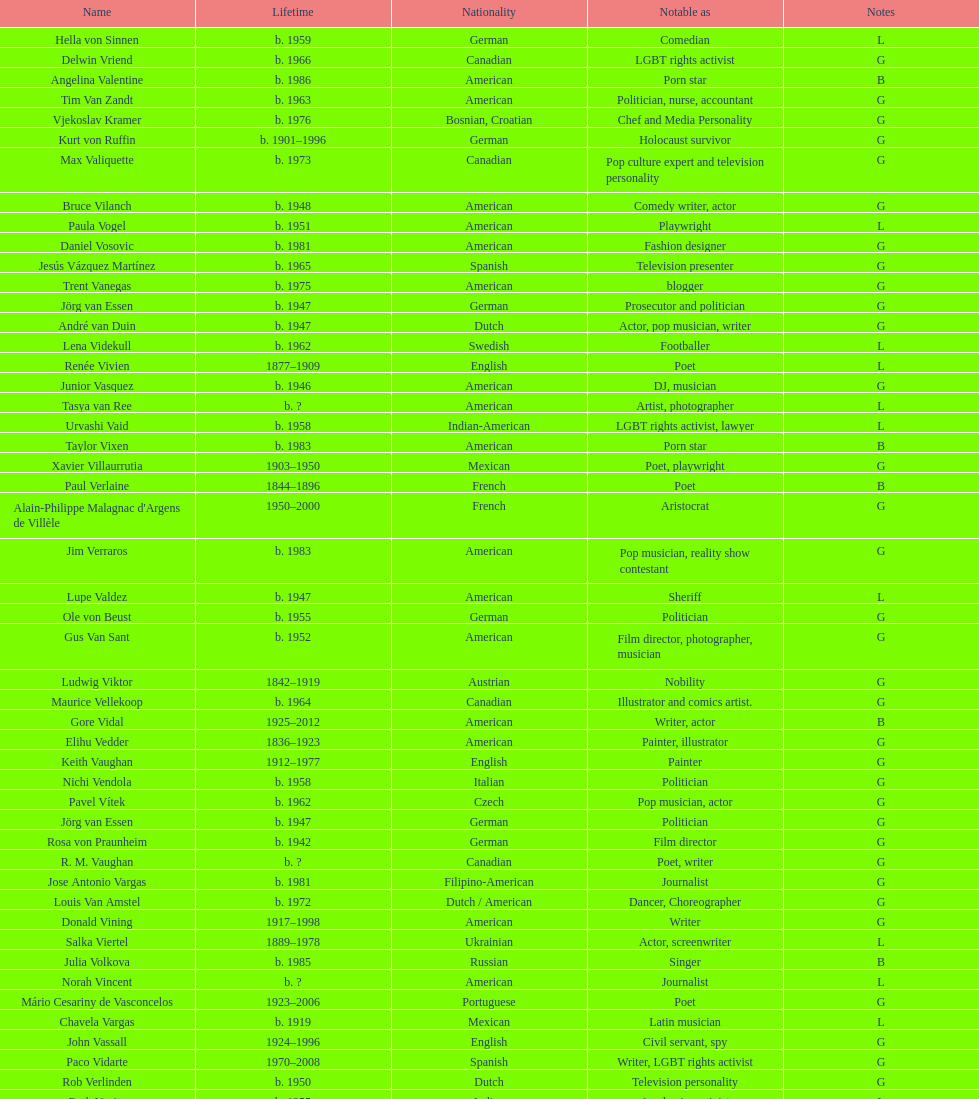Can you parse all the data within this table? {'header': ['Name', 'Lifetime', 'Nationality', 'Notable as', 'Notes'], 'rows': [['Hella von Sinnen', 'b. 1959', 'German', 'Comedian', 'L'], ['Delwin Vriend', 'b. 1966', 'Canadian', 'LGBT rights activist', 'G'], ['Angelina Valentine', 'b. 1986', 'American', 'Porn star', 'B'], ['Tim Van Zandt', 'b. 1963', 'American', 'Politician, nurse, accountant', 'G'], ['Vjekoslav Kramer', 'b. 1976', 'Bosnian, Croatian', 'Chef and Media Personality', 'G'], ['Kurt von Ruffin', 'b. 1901–1996', 'German', 'Holocaust survivor', 'G'], ['Max Valiquette', 'b. 1973', 'Canadian', 'Pop culture expert and television personality', 'G'], ['Bruce Vilanch', 'b. 1948', 'American', 'Comedy writer, actor', 'G'], ['Paula Vogel', 'b. 1951', 'American', 'Playwright', 'L'], ['Daniel Vosovic', 'b. 1981', 'American', 'Fashion designer', 'G'], ['Jesús Vázquez Martínez', 'b. 1965', 'Spanish', 'Television presenter', 'G'], ['Trent Vanegas', 'b. 1975', 'American', 'blogger', 'G'], ['Jörg van Essen', 'b. 1947', 'German', 'Prosecutor and politician', 'G'], ['André van Duin', 'b. 1947', 'Dutch', 'Actor, pop musician, writer', 'G'], ['Lena Videkull', 'b. 1962', 'Swedish', 'Footballer', 'L'], ['Renée Vivien', '1877–1909', 'English', 'Poet', 'L'], ['Junior Vasquez', 'b. 1946', 'American', 'DJ, musician', 'G'], ['Tasya van Ree', 'b.\xa0?', 'American', 'Artist, photographer', 'L'], ['Urvashi Vaid', 'b. 1958', 'Indian-American', 'LGBT rights activist, lawyer', 'L'], ['Taylor Vixen', 'b. 1983', 'American', 'Porn star', 'B'], ['Xavier Villaurrutia', '1903–1950', 'Mexican', 'Poet, playwright', 'G'], ['Paul Verlaine', '1844–1896', 'French', 'Poet', 'B'], ["Alain-Philippe Malagnac d'Argens de Villèle", '1950–2000', 'French', 'Aristocrat', 'G'], ['Jim Verraros', 'b. 1983', 'American', 'Pop musician, reality show contestant', 'G'], ['Lupe Valdez', 'b. 1947', 'American', 'Sheriff', 'L'], ['Ole von Beust', 'b. 1955', 'German', 'Politician', 'G'], ['Gus Van Sant', 'b. 1952', 'American', 'Film director, photographer, musician', 'G'], ['Ludwig Viktor', '1842–1919', 'Austrian', 'Nobility', 'G'], ['Maurice Vellekoop', 'b. 1964', 'Canadian', 'Illustrator and comics artist.', 'G'], ['Gore Vidal', '1925–2012', 'American', 'Writer, actor', 'B'], ['Elihu Vedder', '1836–1923', 'American', 'Painter, illustrator', 'G'], ['Keith Vaughan', '1912–1977', 'English', 'Painter', 'G'], ['Nichi Vendola', 'b. 1958', 'Italian', 'Politician', 'G'], ['Pavel Vítek', 'b. 1962', 'Czech', 'Pop musician, actor', 'G'], ['Jörg van Essen', 'b. 1947', 'German', 'Politician', 'G'], ['Rosa von Praunheim', 'b. 1942', 'German', 'Film director', 'G'], ['R. M. Vaughan', 'b.\xa0?', 'Canadian', 'Poet, writer', 'G'], ['Jose Antonio Vargas', 'b. 1981', 'Filipino-American', 'Journalist', 'G'], ['Louis Van Amstel', 'b. 1972', 'Dutch / American', 'Dancer, Choreographer', 'G'], ['Donald Vining', '1917–1998', 'American', 'Writer', 'G'], ['Salka Viertel', '1889–1978', 'Ukrainian', 'Actor, screenwriter', 'L'], ['Julia Volkova', 'b. 1985', 'Russian', 'Singer', 'B'], ['Norah Vincent', 'b.\xa0?', 'American', 'Journalist', 'L'], ['Mário Cesariny de Vasconcelos', '1923–2006', 'Portuguese', 'Poet', 'G'], ['Chavela Vargas', 'b. 1919', 'Mexican', 'Latin musician', 'L'], ['John Vassall', '1924–1996', 'English', 'Civil servant, spy', 'G'], ['Paco Vidarte', '1970–2008', 'Spanish', 'Writer, LGBT rights activist', 'G'], ['Rob Verlinden', 'b. 1950', 'Dutch', 'Television personality', 'G'], ['Ruth Vanita', 'b. 1955', 'Indian', 'Academic, activist', 'L'], ['Claude Vivier', '1948–1983', 'Canadian', '20th century classical composer', 'G'], ['Arthur H. Vandenberg, Jr.', 'b. 1907', 'American', 'government official, politician', 'G'], ['António Variações', '1944–1984', 'Portuguese', 'Pop musician', 'G'], ['Gianni Versace', '1946–1997', 'Italian', 'Fashion designer', 'G'], ['Wilhelm von Gloeden', '1856–1931', 'German', 'Photographer', 'G'], ['Théophile de Viau', '1590–1626', 'French', 'Poet, dramatist', 'G'], ['Jennifer Veiga', 'b. 1962', 'American', 'Politician', 'L'], ['Ron Vawter', '1948–1994', 'American', 'Actor', 'G'], ['Bruce Voeller', '1934–1994', 'American', 'HIV/AIDS researcher', 'G'], ['Börje Vestlund', 'b. 1960', 'Swedish', 'Politician', 'G'], ['Luchino Visconti', '1906–1976', 'Italian', 'Filmmaker', 'G'], ['Reg Vermue', 'b.\xa0?', 'Canadian', 'Rock musician', 'G'], ['Werner Veigel', '1928–1995', 'German', 'News presenter', 'G'], ['Anthony Venn-Brown', 'b. 1951', 'Australian', 'Author, former evangelist', 'G'], ['Carmen Vázquez', 'b.\xa0?', 'Cuban-American', 'Activist, writer', 'L'], ['Carl Van Vechten', '1880–1964', 'American', 'Writer, photographer', 'G'], ['Patricia Velásquez', 'b. 1971', 'Venezuelan', 'Actor, model', 'B'], ['Tom Villard', '1953–1994', 'American', 'Actor', 'G'], ['Christine Vachon', 'b. 1962', 'American', 'Film producer', 'L'], ['Gerda Verburg', 'b. 1957', 'Dutch', 'Politician', 'L'], ['Gianni Vattimo', 'b. 1936', 'Italian', 'Writer, philosopher', 'G'], ['José Villarrubia', 'b. 1961', 'American', 'Artist', 'G'], ['Nick Verreos', 'b. 1967', 'American', 'Fashion designer', 'G'], ['Pierre Vallières', '1938–1998', 'Québécois', 'Journalist, writer', 'G']]} What profession did patricia velasquez and ron vawter both share? Actor. 